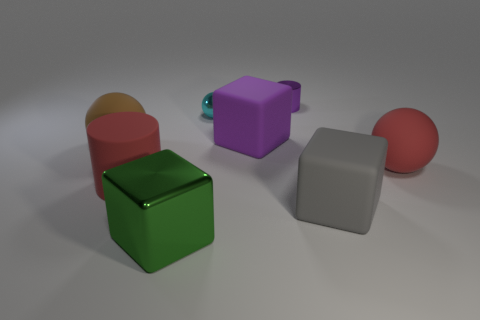What is the shape of the big thing that is in front of the big gray cube?
Your response must be concise. Cube. Is the material of the small purple cylinder the same as the large green cube that is in front of the large red sphere?
Ensure brevity in your answer.  Yes. Is there a green metallic ball?
Ensure brevity in your answer.  No. There is a matte block that is in front of the cylinder that is to the left of the small metal cylinder; is there a matte cube to the left of it?
Offer a very short reply. Yes. How many large things are either red metallic things or purple matte blocks?
Provide a succinct answer. 1. The matte cylinder that is the same size as the green metallic object is what color?
Your answer should be compact. Red. There is a large red matte sphere; what number of large gray cubes are to the left of it?
Your response must be concise. 1. Is there a tiny purple object that has the same material as the green cube?
Your response must be concise. Yes. What shape is the matte object that is the same color as the shiny cylinder?
Offer a very short reply. Cube. The rubber ball to the left of the green shiny block is what color?
Give a very brief answer. Brown. 